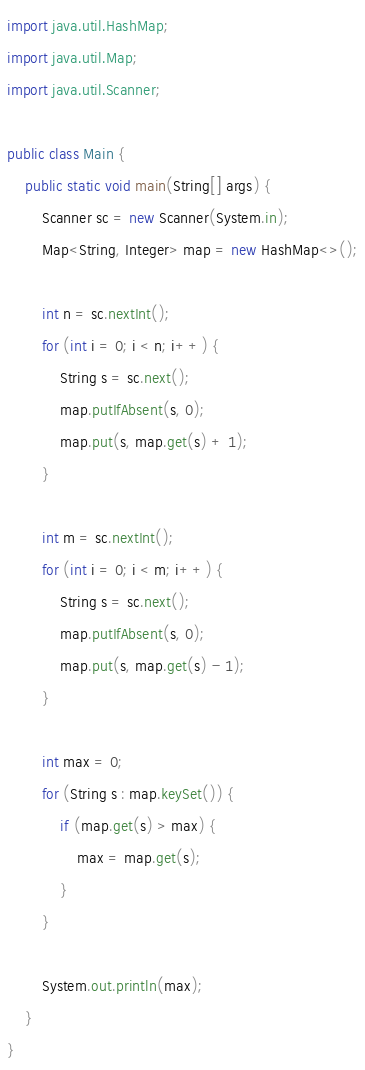Convert code to text. <code><loc_0><loc_0><loc_500><loc_500><_Java_>import java.util.HashMap;
import java.util.Map;
import java.util.Scanner;

public class Main {
    public static void main(String[] args) {
        Scanner sc = new Scanner(System.in);
        Map<String, Integer> map = new HashMap<>();

        int n = sc.nextInt();
        for (int i = 0; i < n; i++) {
            String s = sc.next();
            map.putIfAbsent(s, 0);
            map.put(s, map.get(s) + 1);
        }

        int m = sc.nextInt();
        for (int i = 0; i < m; i++) {
            String s = sc.next();
            map.putIfAbsent(s, 0);
            map.put(s, map.get(s) - 1);
        }

        int max = 0;
        for (String s : map.keySet()) {
            if (map.get(s) > max) {
                max = map.get(s);
            }
        }

        System.out.println(max);
    }
}
</code> 